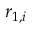<formula> <loc_0><loc_0><loc_500><loc_500>r _ { 1 , i }</formula> 